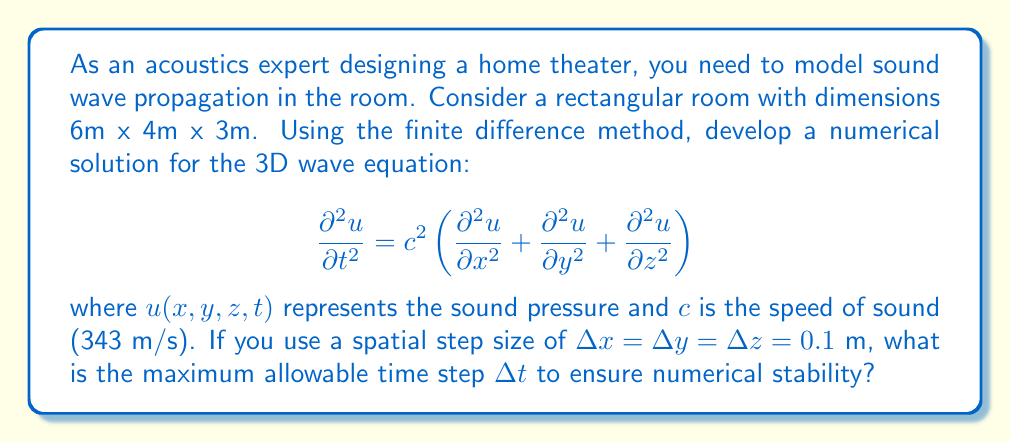Give your solution to this math problem. To solve this problem, we need to use the Courant-Friedrichs-Lewy (CFL) condition for the 3D wave equation using the finite difference method. The CFL condition ensures numerical stability of the solution.

For the 3D wave equation, the CFL condition is:

$$\Delta t \leq \frac{\Delta x}{c\sqrt{3}}$$

Where:
- $\Delta t$ is the time step
- $\Delta x$ is the spatial step (assuming $\Delta x = \Delta y = \Delta z$)
- $c$ is the speed of sound

Given:
- $c = 343$ m/s
- $\Delta x = \Delta y = \Delta z = 0.1$ m

Let's substitute these values into the CFL condition:

$$\Delta t \leq \frac{0.1}{343\sqrt{3}}$$

Now, let's calculate the right-hand side:

$$\frac{0.1}{343\sqrt{3}} \approx 1.68 \times 10^{-4}$$

Therefore, to ensure numerical stability, we must choose a time step $\Delta t$ that is less than or equal to this value.
Answer: The maximum allowable time step $\Delta t$ to ensure numerical stability is approximately $1.68 \times 10^{-4}$ seconds. 